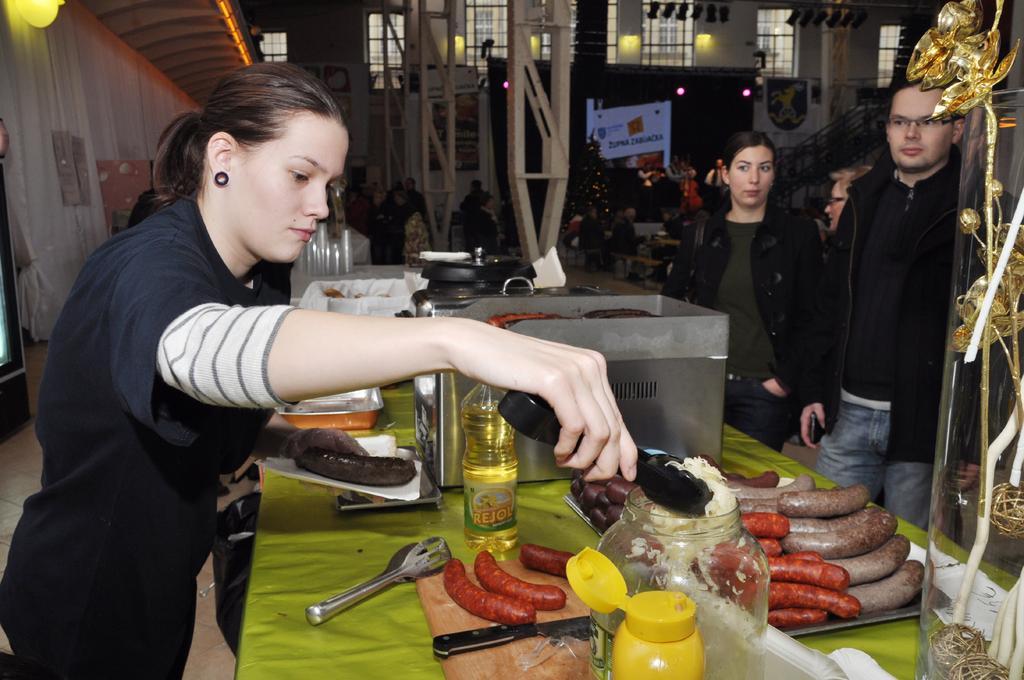Can you describe this image briefly? In front of the image there is a woman holding tongs in her hand, in front of the woman on the table there are hot dogs, tongs, bottle of oil and some other objects, in front of the table there are a few people standing, in the background of the image there are a few other people, there are metal rods, a screen, on top of the image there are lights, behind the screen on the wall there are banners, on top of the banners there are windows with metal rods, behind the woman there is a curtain, on the curtain there are posters and there are some objects, on top of the curtain there are lamps. 